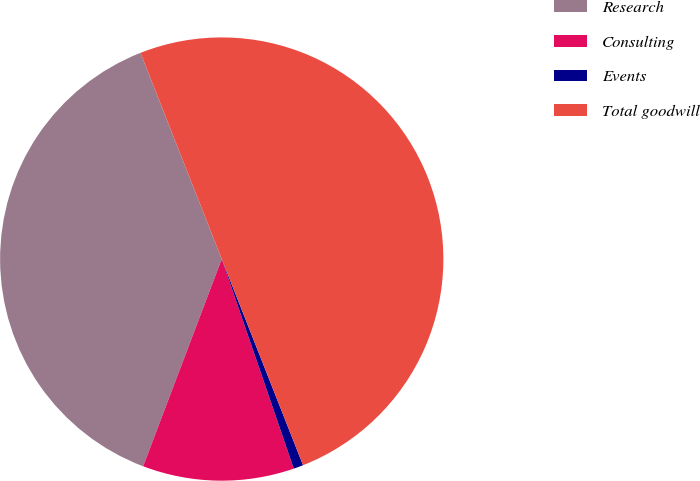Convert chart to OTSL. <chart><loc_0><loc_0><loc_500><loc_500><pie_chart><fcel>Research<fcel>Consulting<fcel>Events<fcel>Total goodwill<nl><fcel>38.26%<fcel>11.04%<fcel>0.71%<fcel>50.0%<nl></chart> 